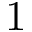<formula> <loc_0><loc_0><loc_500><loc_500>1</formula> 